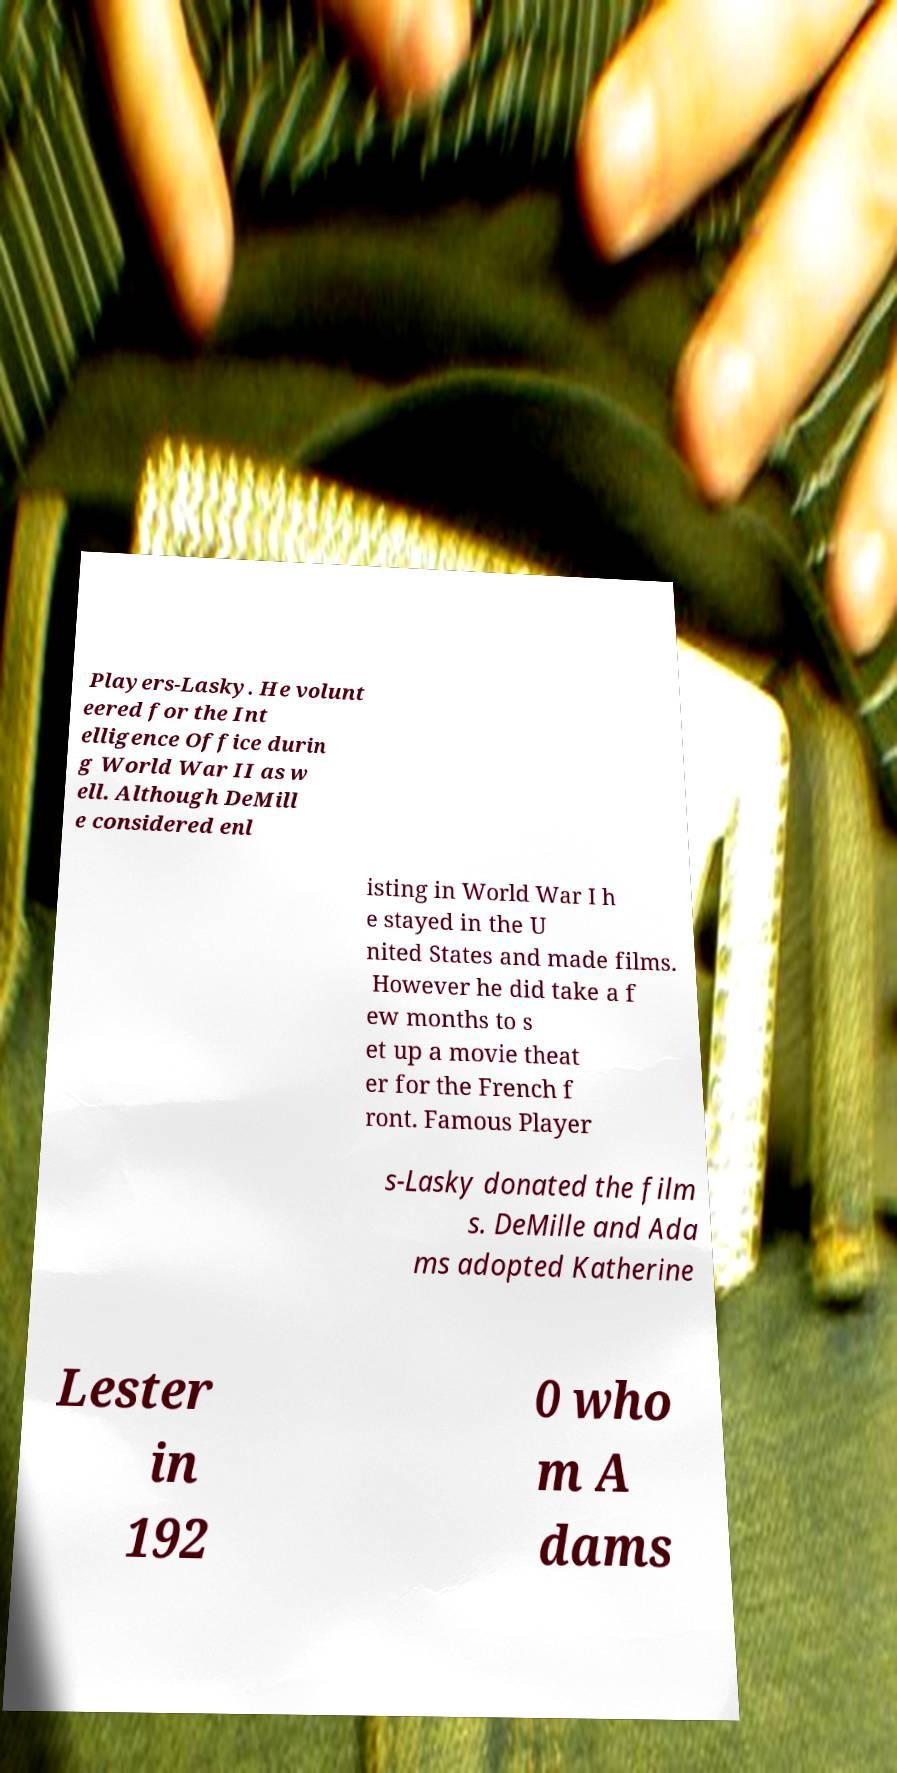What messages or text are displayed in this image? I need them in a readable, typed format. Players-Lasky. He volunt eered for the Int elligence Office durin g World War II as w ell. Although DeMill e considered enl isting in World War I h e stayed in the U nited States and made films. However he did take a f ew months to s et up a movie theat er for the French f ront. Famous Player s-Lasky donated the film s. DeMille and Ada ms adopted Katherine Lester in 192 0 who m A dams 